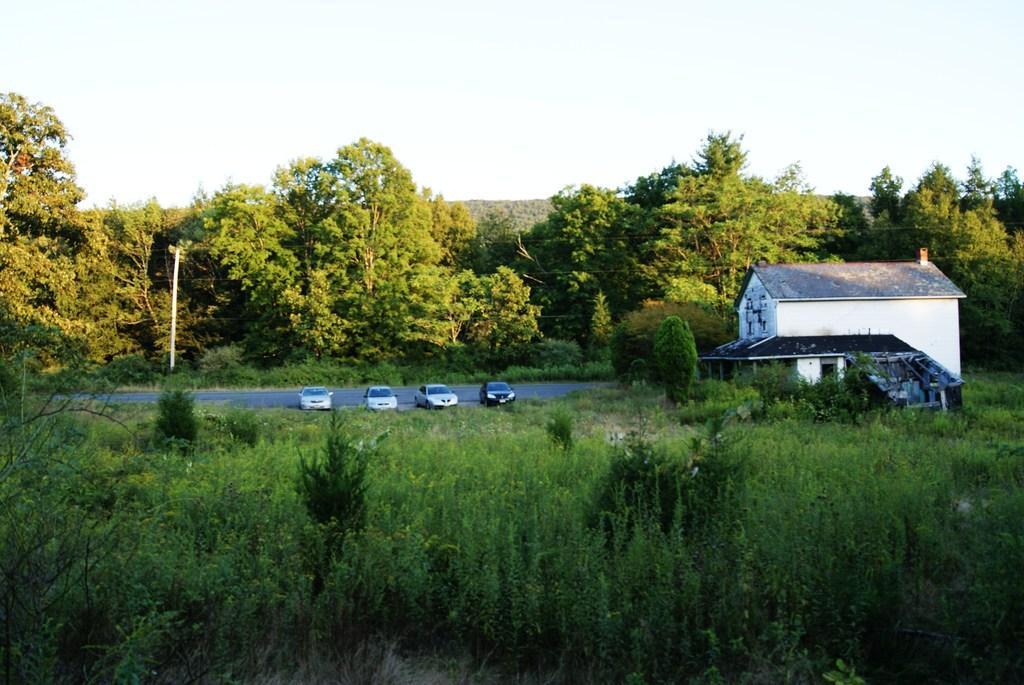Could you give a brief overview of what you see in this image? In the center of the image we can see cars, road, trees, pole, houses are there. At the top of the image sky is there. 